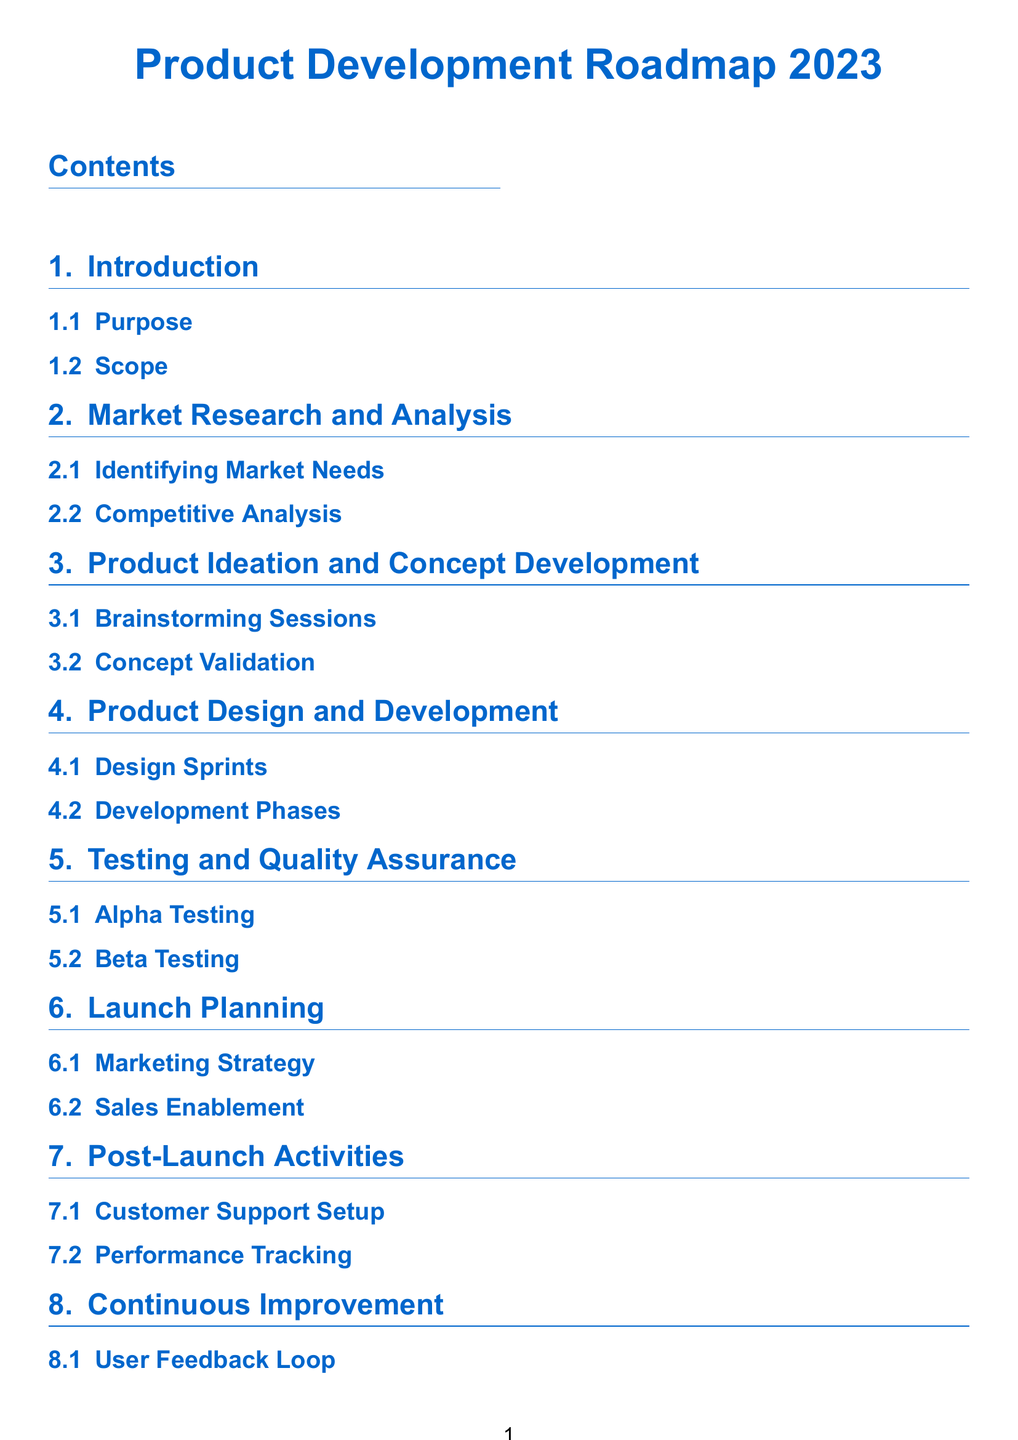what is the title of the document? The title is prominently displayed at the top of the document, introducing the subject matter.
Answer: Product Development Roadmap 2023 how many main sections are there in the document? By counting the sections listed in the table of contents, we find the number of main topic areas covered.
Answer: 8 what is the first subsection under Market Research and Analysis? The first subsection is listed clearly under the Market Research and Analysis section in the document.
Answer: Identifying Market Needs which section includes Alpha Testing? The section that includes Alpha Testing is identified in the table of contents, showing the sequence of topics.
Answer: Testing and Quality Assurance what is the focus of the Continuous Improvement section? The focus of this section can be found in the subsection headings that follow it.
Answer: User Feedback Loop what comes after Product Ideation and Concept Development? This question looks for the subsequent section listed in the table of contents, directly following the current one.
Answer: Product Design and Development how many subsections are under Launch Planning? This counts the specific subsections detailed under the Launch Planning section to understand its depth.
Answer: 2 what is the purpose of the document section? The purpose is essential and defined early in the document layout, addressing the aims of the roadmap.
Answer: Purpose 